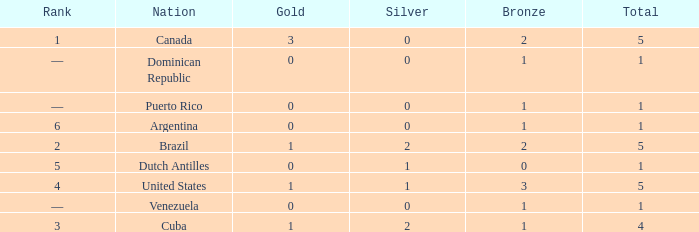What is the average gold total for nations ranked 6 with 1 total medal and 1 bronze medal? None. Could you help me parse every detail presented in this table? {'header': ['Rank', 'Nation', 'Gold', 'Silver', 'Bronze', 'Total'], 'rows': [['1', 'Canada', '3', '0', '2', '5'], ['—', 'Dominican Republic', '0', '0', '1', '1'], ['—', 'Puerto Rico', '0', '0', '1', '1'], ['6', 'Argentina', '0', '0', '1', '1'], ['2', 'Brazil', '1', '2', '2', '5'], ['5', 'Dutch Antilles', '0', '1', '0', '1'], ['4', 'United States', '1', '1', '3', '5'], ['—', 'Venezuela', '0', '0', '1', '1'], ['3', 'Cuba', '1', '2', '1', '4']]} 